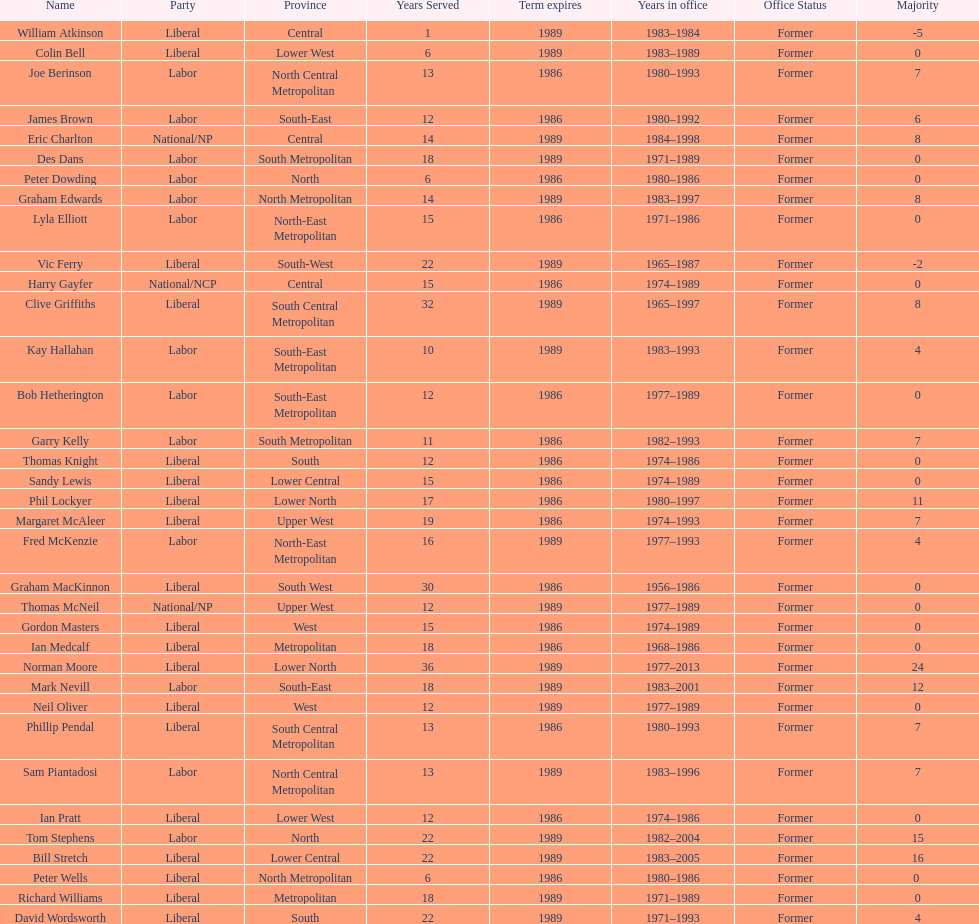What is the number of people in the liberal party? 19. 